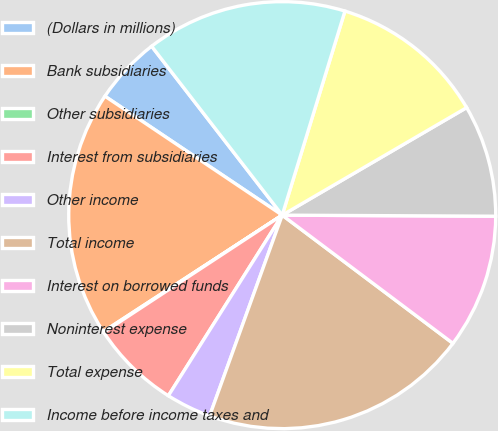<chart> <loc_0><loc_0><loc_500><loc_500><pie_chart><fcel>(Dollars in millions)<fcel>Bank subsidiaries<fcel>Other subsidiaries<fcel>Interest from subsidiaries<fcel>Other income<fcel>Total income<fcel>Interest on borrowed funds<fcel>Noninterest expense<fcel>Total expense<fcel>Income before income taxes and<nl><fcel>5.12%<fcel>18.59%<fcel>0.06%<fcel>6.8%<fcel>3.43%<fcel>20.27%<fcel>10.17%<fcel>8.48%<fcel>11.85%<fcel>15.22%<nl></chart> 